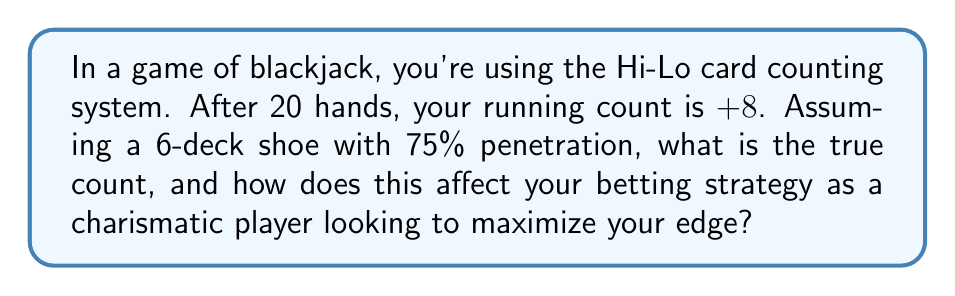Could you help me with this problem? To solve this problem, we need to follow these steps:

1. Understand the Hi-Lo system:
   The Hi-Lo system assigns values to cards:
   - 2-6: +1
   - 7-9: 0
   - 10-Ace: -1

2. Calculate the number of decks remaining:
   - Total decks in shoe: 6
   - Penetration: 75% = 0.75
   - Decks played: $6 \times 0.75 = 4.5$
   - Decks remaining: $6 - 4.5 = 1.5$

3. Calculate the true count:
   True Count = Running Count ÷ Decks Remaining
   $$ \text{True Count} = \frac{\text{Running Count}}{\text{Decks Remaining}} = \frac{8}{1.5} \approx 5.33 $$

4. Interpret the true count:
   A true count of +5.33 is considered very high, indicating a strong player advantage.

5. Betting strategy:
   As a charismatic player looking to maximize your edge:
   - Increase your bet size significantly (e.g., 5-10 times your minimum bet)
   - Use your charisma to distract other players and the dealer from your increased bets
   - Consider using more aggressive playing strategies (e.g., splitting pairs more often, doubling down on more hands)
Answer: True Count: +5.33. Significantly increase bets and play more aggressively. 